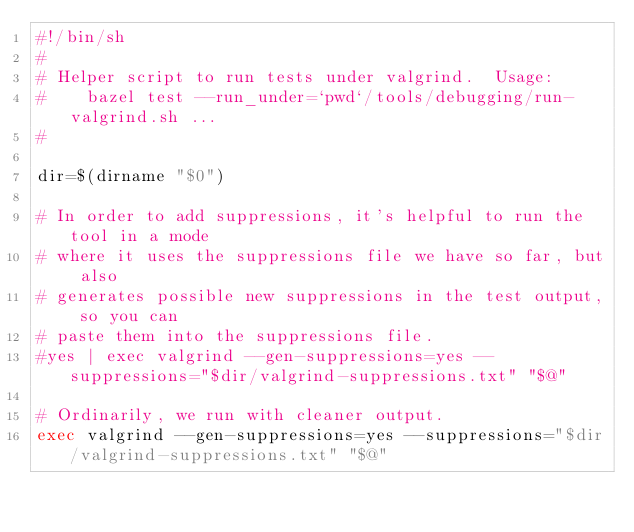Convert code to text. <code><loc_0><loc_0><loc_500><loc_500><_Bash_>#!/bin/sh
#
# Helper script to run tests under valgrind.  Usage:
#    bazel test --run_under=`pwd`/tools/debugging/run-valgrind.sh ...
#

dir=$(dirname "$0")

# In order to add suppressions, it's helpful to run the tool in a mode
# where it uses the suppressions file we have so far, but also
# generates possible new suppressions in the test output, so you can
# paste them into the suppressions file.
#yes | exec valgrind --gen-suppressions=yes --suppressions="$dir/valgrind-suppressions.txt" "$@"

# Ordinarily, we run with cleaner output.
exec valgrind --gen-suppressions=yes --suppressions="$dir/valgrind-suppressions.txt" "$@"
</code> 